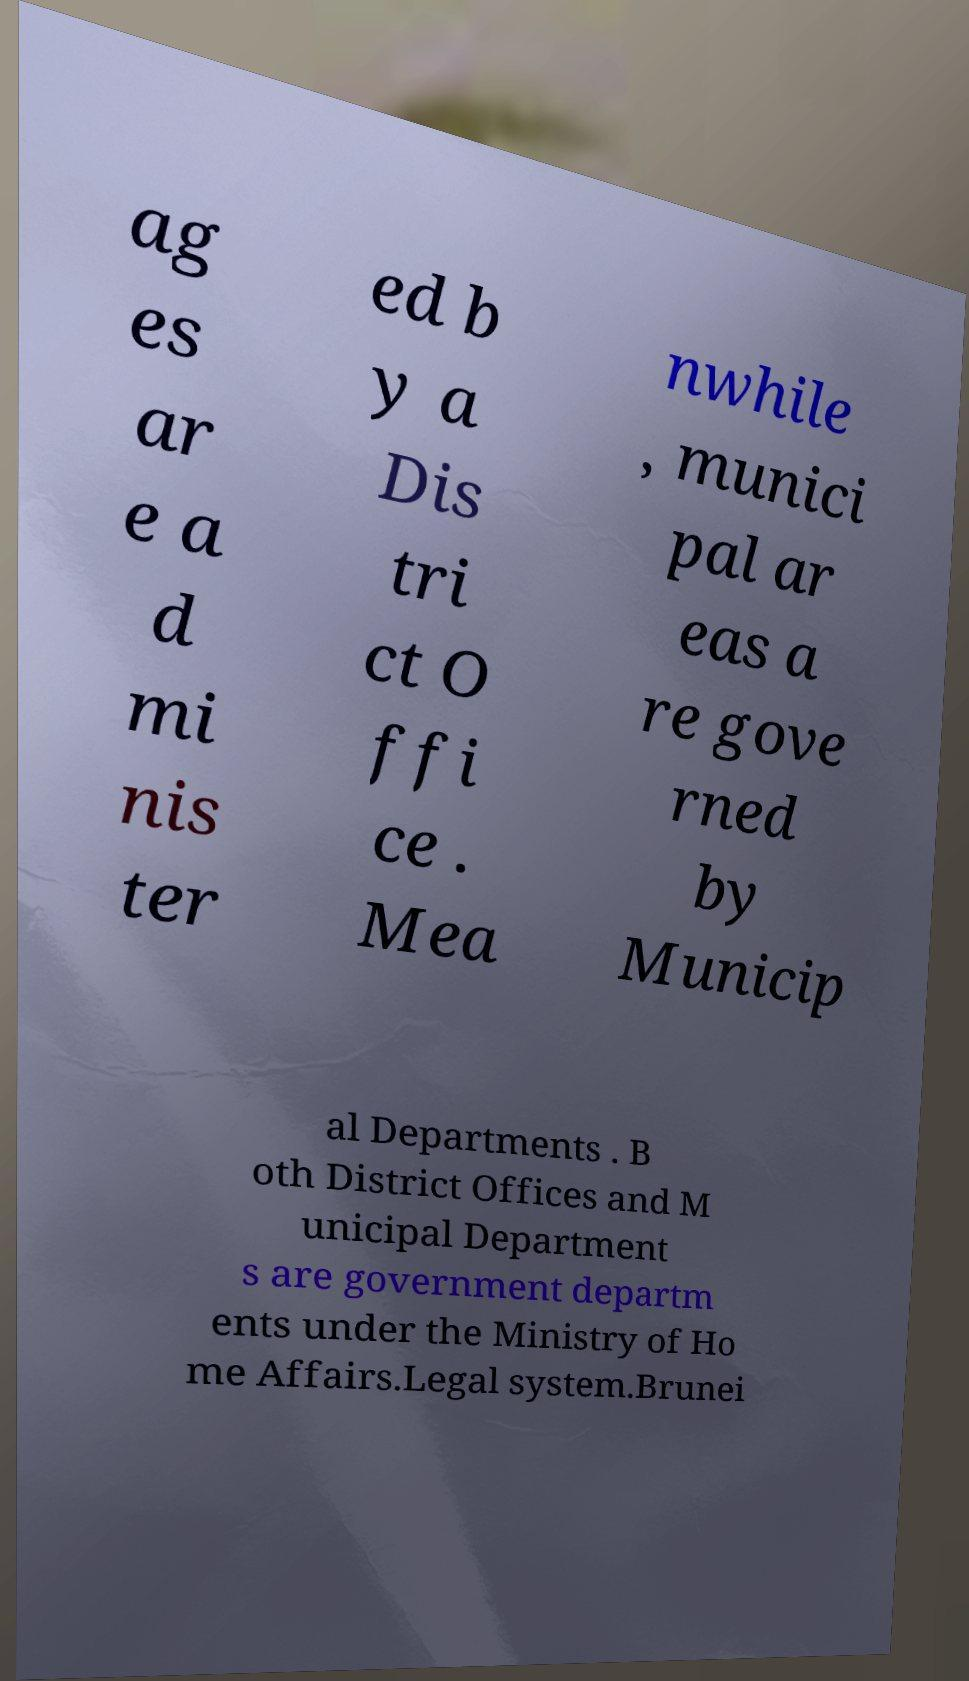Could you assist in decoding the text presented in this image and type it out clearly? ag es ar e a d mi nis ter ed b y a Dis tri ct O ffi ce . Mea nwhile , munici pal ar eas a re gove rned by Municip al Departments . B oth District Offices and M unicipal Department s are government departm ents under the Ministry of Ho me Affairs.Legal system.Brunei 